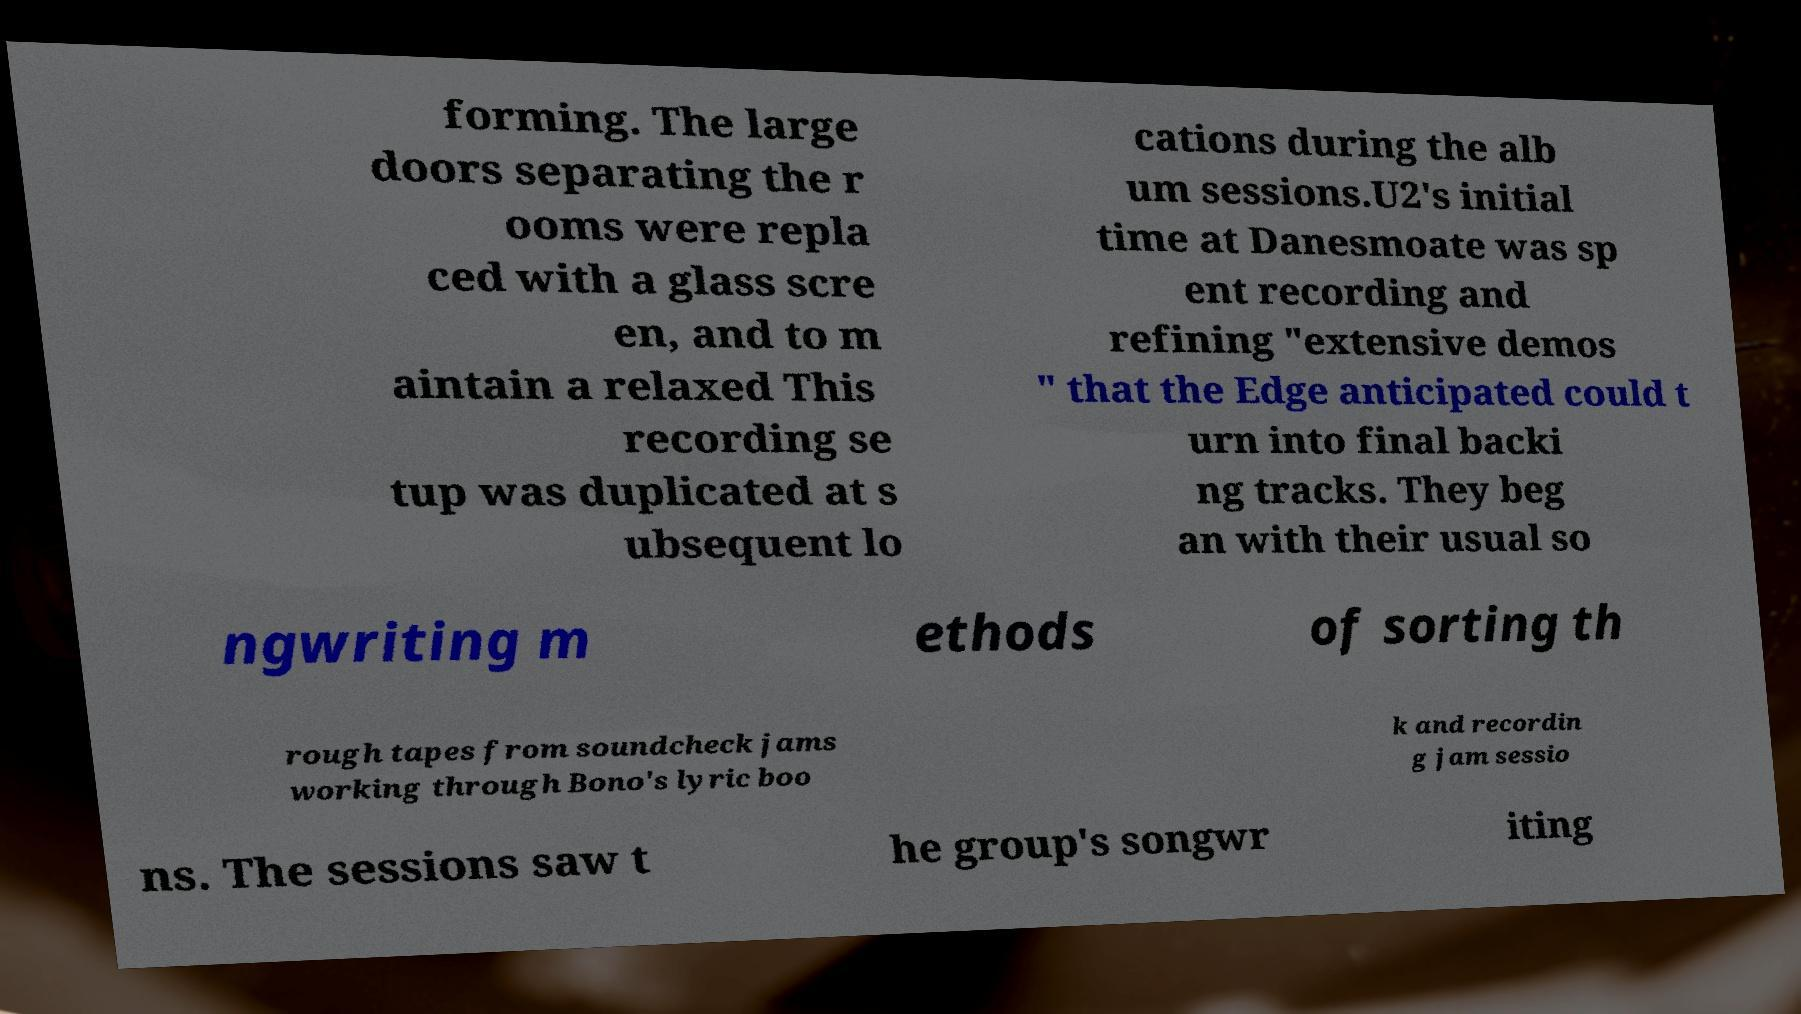Could you extract and type out the text from this image? forming. The large doors separating the r ooms were repla ced with a glass scre en, and to m aintain a relaxed This recording se tup was duplicated at s ubsequent lo cations during the alb um sessions.U2's initial time at Danesmoate was sp ent recording and refining "extensive demos " that the Edge anticipated could t urn into final backi ng tracks. They beg an with their usual so ngwriting m ethods of sorting th rough tapes from soundcheck jams working through Bono's lyric boo k and recordin g jam sessio ns. The sessions saw t he group's songwr iting 